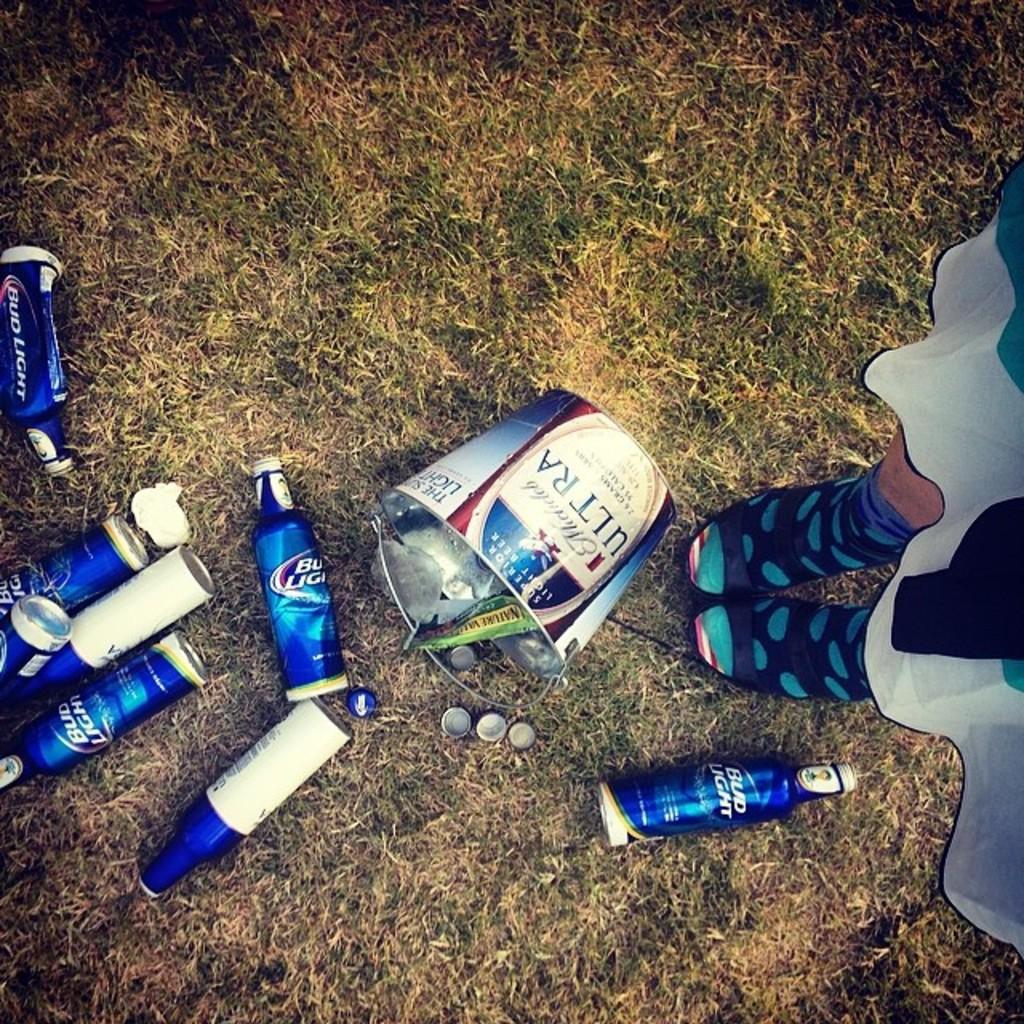What is the brand of beer in the blue bottle?
Make the answer very short. Bud light. 